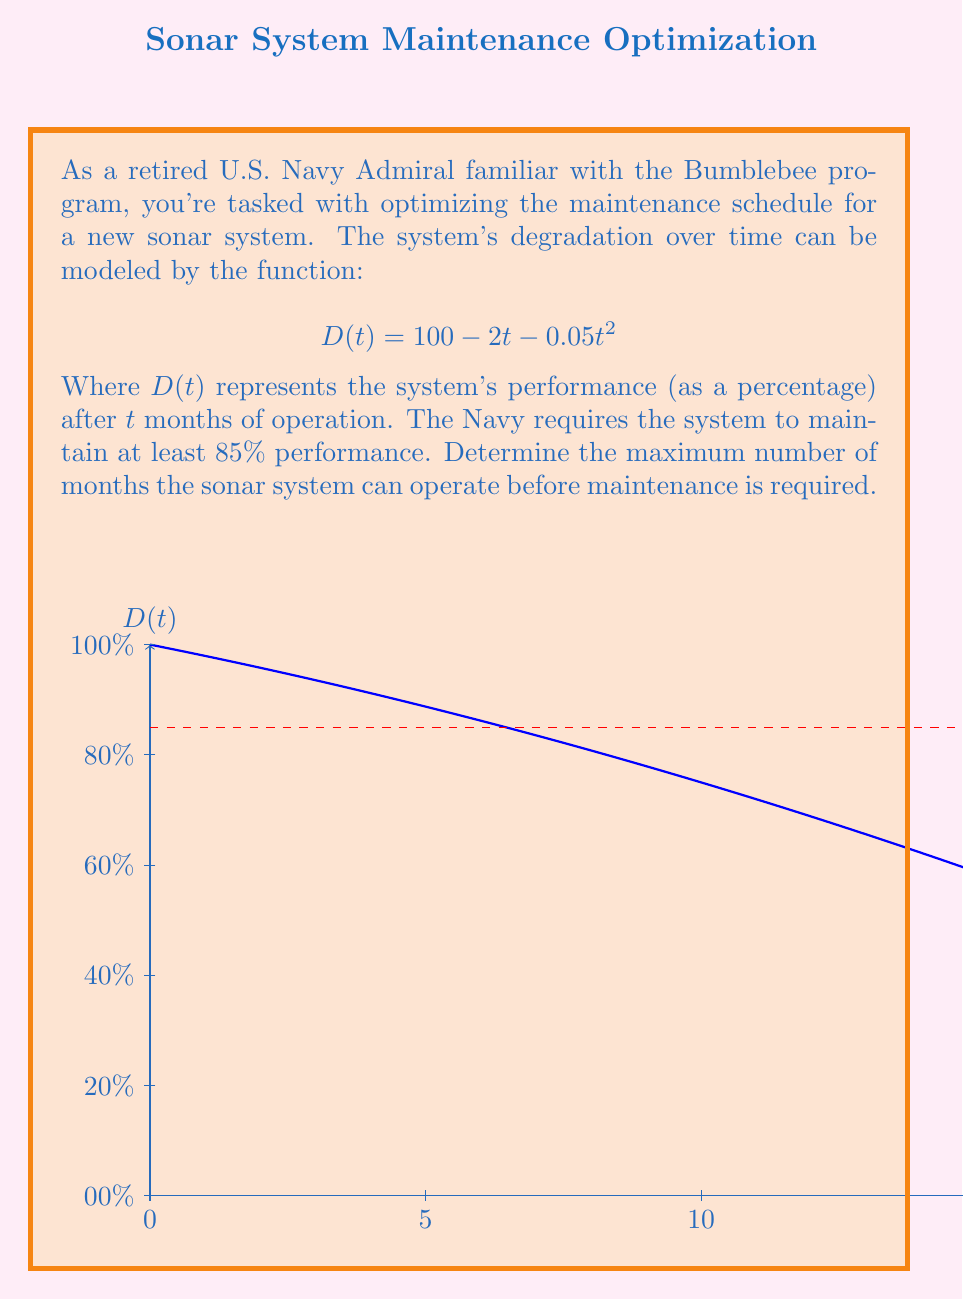What is the answer to this math problem? Let's approach this step-by-step:

1) We need to find the time $t$ when the performance $D(t)$ drops to 85%. This can be represented by the equation:

   $$85 = 100 - 2t - 0.05t^2$$

2) Rearranging the equation:

   $$0.05t^2 + 2t - 15 = 0$$

3) This is a quadratic equation in the form $ax^2 + bx + c = 0$, where:
   $a = 0.05$, $b = 2$, and $c = -15$

4) We can solve this using the quadratic formula: 

   $$t = \frac{-b \pm \sqrt{b^2 - 4ac}}{2a}$$

5) Substituting our values:

   $$t = \frac{-2 \pm \sqrt{2^2 - 4(0.05)(-15)}}{2(0.05)}$$

6) Simplifying:

   $$t = \frac{-2 \pm \sqrt{4 + 3}}{0.1} = \frac{-2 \pm \sqrt{7}}{0.1}$$

7) This gives us two solutions:

   $$t_1 = \frac{-2 + \sqrt{7}}{0.1} \approx 6.46$$
   $$t_2 = \frac{-2 - \sqrt{7}}{0.1} \approx -46.46$$

8) Since time cannot be negative, we discard the second solution.

9) The maximum number of months before maintenance is required is the floor of 6.46, which is 6.
Answer: 6 months 